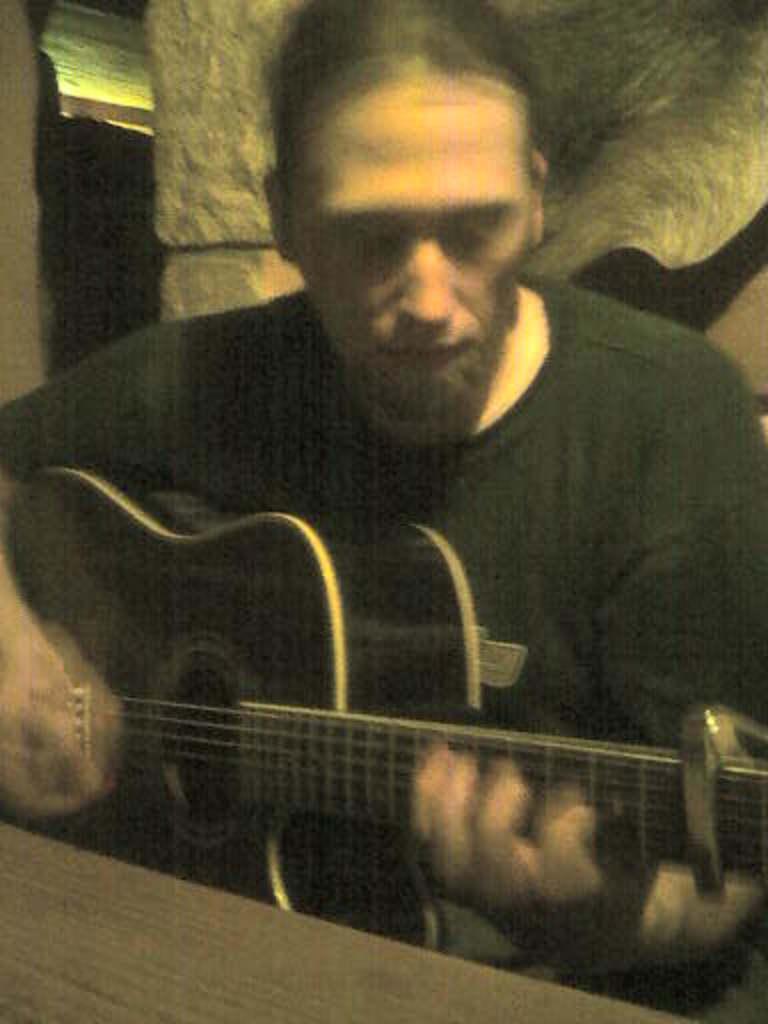In one or two sentences, can you explain what this image depicts? In the image there is a man sitting on chair and holding a guitar and playing it in front of a table. In background we can see a white color wall. 